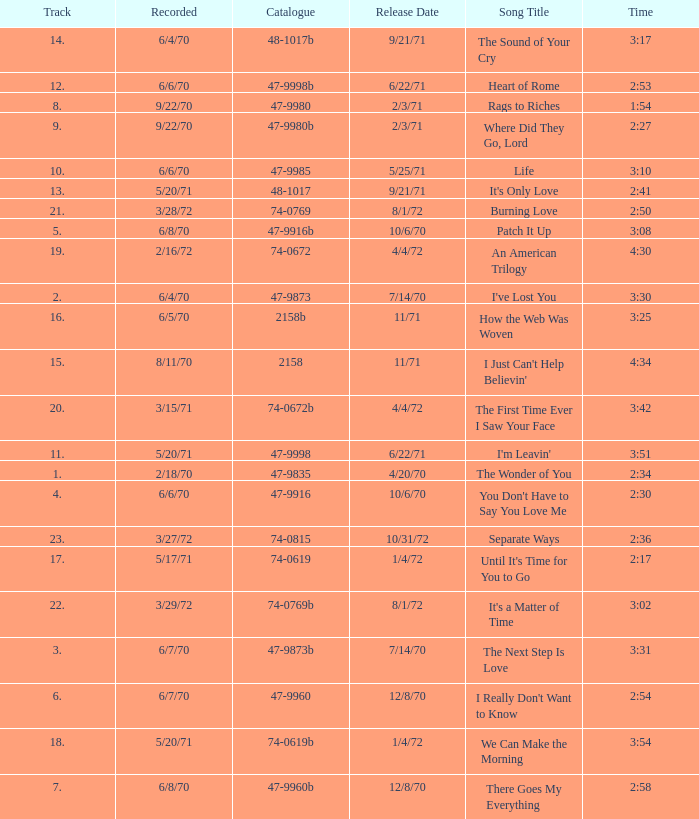Which song was released 12/8/70 with a time of 2:54? I Really Don't Want to Know. Can you parse all the data within this table? {'header': ['Track', 'Recorded', 'Catalogue', 'Release Date', 'Song Title', 'Time'], 'rows': [['14.', '6/4/70', '48-1017b', '9/21/71', 'The Sound of Your Cry', '3:17'], ['12.', '6/6/70', '47-9998b', '6/22/71', 'Heart of Rome', '2:53'], ['8.', '9/22/70', '47-9980', '2/3/71', 'Rags to Riches', '1:54'], ['9.', '9/22/70', '47-9980b', '2/3/71', 'Where Did They Go, Lord', '2:27'], ['10.', '6/6/70', '47-9985', '5/25/71', 'Life', '3:10'], ['13.', '5/20/71', '48-1017', '9/21/71', "It's Only Love", '2:41'], ['21.', '3/28/72', '74-0769', '8/1/72', 'Burning Love', '2:50'], ['5.', '6/8/70', '47-9916b', '10/6/70', 'Patch It Up', '3:08'], ['19.', '2/16/72', '74-0672', '4/4/72', 'An American Trilogy', '4:30'], ['2.', '6/4/70', '47-9873', '7/14/70', "I've Lost You", '3:30'], ['16.', '6/5/70', '2158b', '11/71', 'How the Web Was Woven', '3:25'], ['15.', '8/11/70', '2158', '11/71', "I Just Can't Help Believin'", '4:34'], ['20.', '3/15/71', '74-0672b', '4/4/72', 'The First Time Ever I Saw Your Face', '3:42'], ['11.', '5/20/71', '47-9998', '6/22/71', "I'm Leavin'", '3:51'], ['1.', '2/18/70', '47-9835', '4/20/70', 'The Wonder of You', '2:34'], ['4.', '6/6/70', '47-9916', '10/6/70', "You Don't Have to Say You Love Me", '2:30'], ['23.', '3/27/72', '74-0815', '10/31/72', 'Separate Ways', '2:36'], ['17.', '5/17/71', '74-0619', '1/4/72', "Until It's Time for You to Go", '2:17'], ['22.', '3/29/72', '74-0769b', '8/1/72', "It's a Matter of Time", '3:02'], ['3.', '6/7/70', '47-9873b', '7/14/70', 'The Next Step Is Love', '3:31'], ['6.', '6/7/70', '47-9960', '12/8/70', "I Really Don't Want to Know", '2:54'], ['18.', '5/20/71', '74-0619b', '1/4/72', 'We Can Make the Morning', '3:54'], ['7.', '6/8/70', '47-9960b', '12/8/70', 'There Goes My Everything', '2:58']]} 